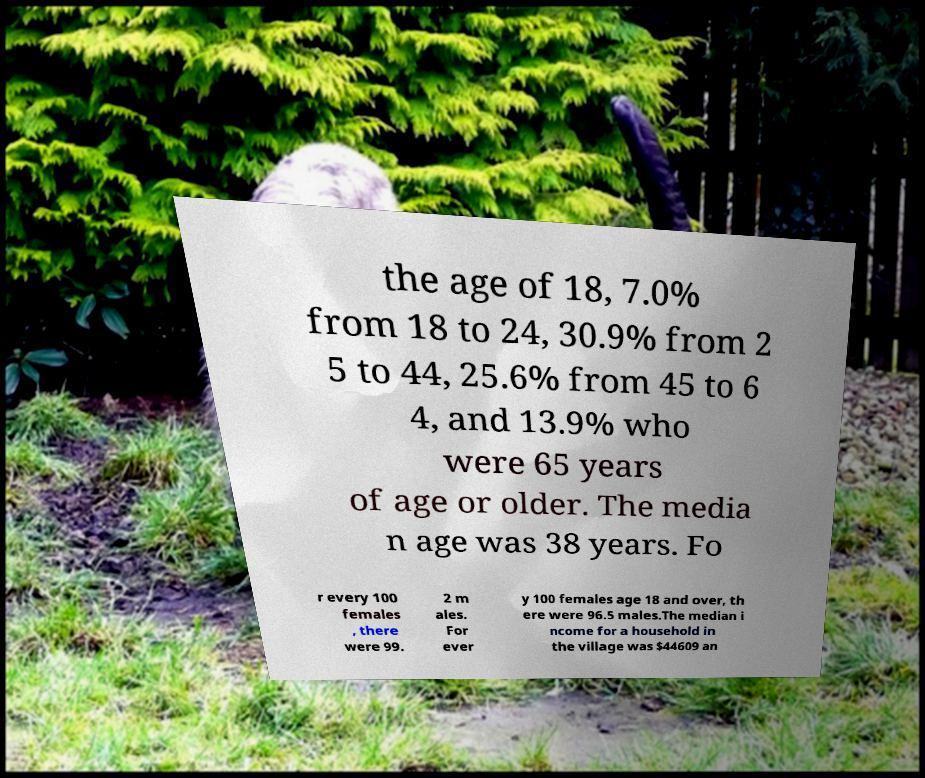Can you read and provide the text displayed in the image?This photo seems to have some interesting text. Can you extract and type it out for me? the age of 18, 7.0% from 18 to 24, 30.9% from 2 5 to 44, 25.6% from 45 to 6 4, and 13.9% who were 65 years of age or older. The media n age was 38 years. Fo r every 100 females , there were 99. 2 m ales. For ever y 100 females age 18 and over, th ere were 96.5 males.The median i ncome for a household in the village was $44609 an 